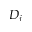Convert formula to latex. <formula><loc_0><loc_0><loc_500><loc_500>D _ { j }</formula> 